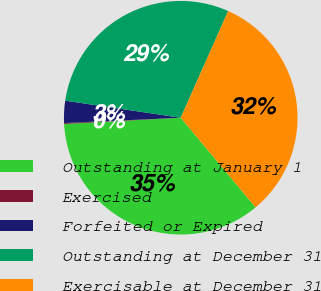<chart> <loc_0><loc_0><loc_500><loc_500><pie_chart><fcel>Outstanding at January 1<fcel>Exercised<fcel>Forfeited or Expired<fcel>Outstanding at December 31<fcel>Exercisable at December 31<nl><fcel>35.22%<fcel>0.12%<fcel>3.06%<fcel>29.32%<fcel>32.27%<nl></chart> 